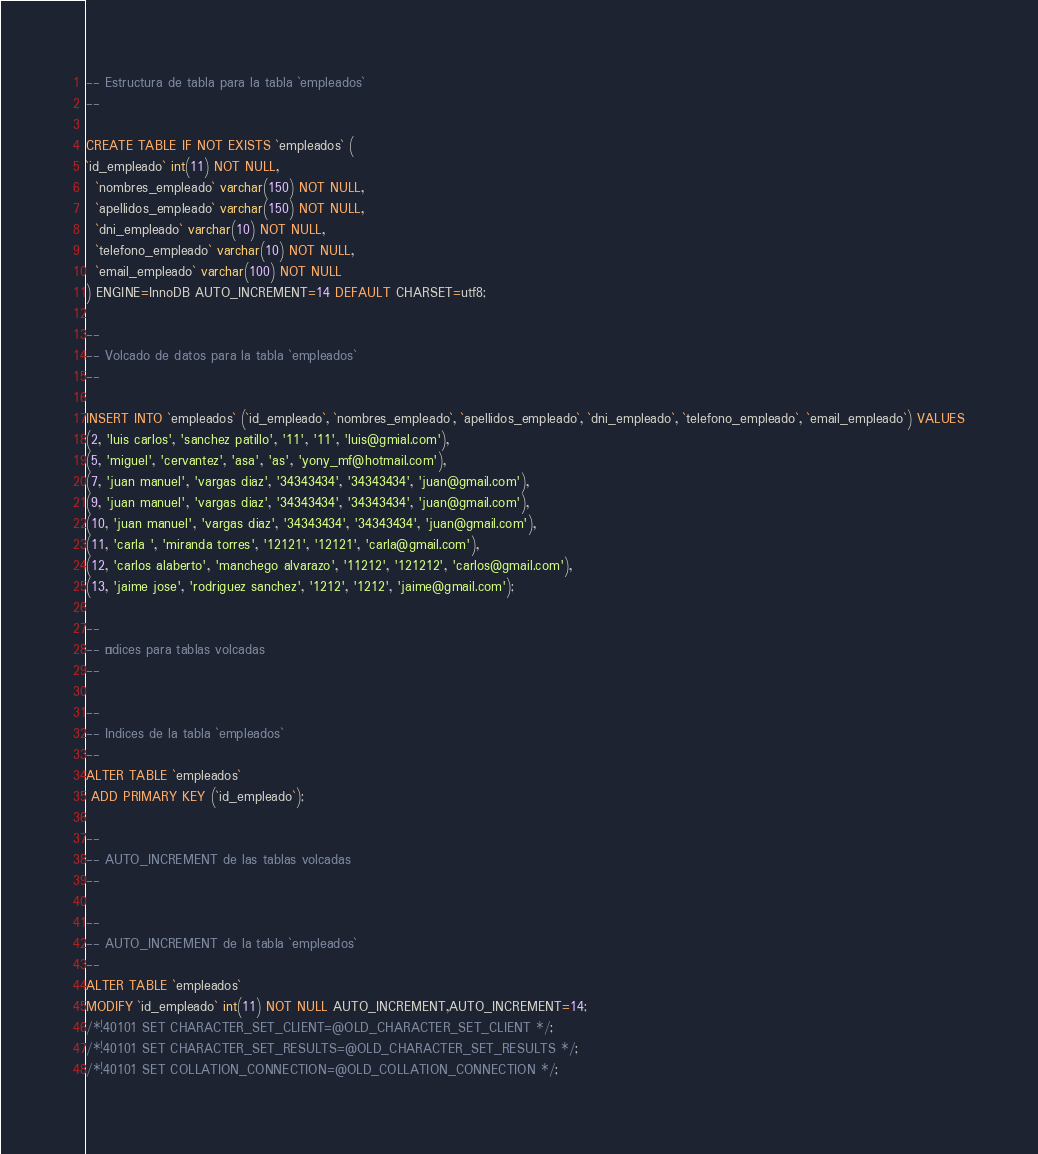Convert code to text. <code><loc_0><loc_0><loc_500><loc_500><_SQL_>-- Estructura de tabla para la tabla `empleados`
--

CREATE TABLE IF NOT EXISTS `empleados` (
`id_empleado` int(11) NOT NULL,
  `nombres_empleado` varchar(150) NOT NULL,
  `apellidos_empleado` varchar(150) NOT NULL,
  `dni_empleado` varchar(10) NOT NULL,
  `telefono_empleado` varchar(10) NOT NULL,
  `email_empleado` varchar(100) NOT NULL
) ENGINE=InnoDB AUTO_INCREMENT=14 DEFAULT CHARSET=utf8;

--
-- Volcado de datos para la tabla `empleados`
--

INSERT INTO `empleados` (`id_empleado`, `nombres_empleado`, `apellidos_empleado`, `dni_empleado`, `telefono_empleado`, `email_empleado`) VALUES
(2, 'luis carlos', 'sanchez patillo', '11', '11', 'luis@gmial.com'),
(5, 'miguel', 'cervantez', 'asa', 'as', 'yony_mf@hotmail.com'),
(7, 'juan manuel', 'vargas diaz', '34343434', '34343434', 'juan@gmail.com'),
(9, 'juan manuel', 'vargas diaz', '34343434', '34343434', 'juan@gmail.com'),
(10, 'juan manuel', 'vargas diaz', '34343434', '34343434', 'juan@gmail.com'),
(11, 'carla ', 'miranda torres', '12121', '12121', 'carla@gmail.com'),
(12, 'carlos alaberto', 'manchego alvarazo', '11212', '121212', 'carlos@gmail.com'),
(13, 'jaime jose', 'rodriguez sanchez', '1212', '1212', 'jaime@gmail.com');

--
-- Índices para tablas volcadas
--

--
-- Indices de la tabla `empleados`
--
ALTER TABLE `empleados`
 ADD PRIMARY KEY (`id_empleado`);

--
-- AUTO_INCREMENT de las tablas volcadas
--

--
-- AUTO_INCREMENT de la tabla `empleados`
--
ALTER TABLE `empleados`
MODIFY `id_empleado` int(11) NOT NULL AUTO_INCREMENT,AUTO_INCREMENT=14;
/*!40101 SET CHARACTER_SET_CLIENT=@OLD_CHARACTER_SET_CLIENT */;
/*!40101 SET CHARACTER_SET_RESULTS=@OLD_CHARACTER_SET_RESULTS */;
/*!40101 SET COLLATION_CONNECTION=@OLD_COLLATION_CONNECTION */;
</code> 